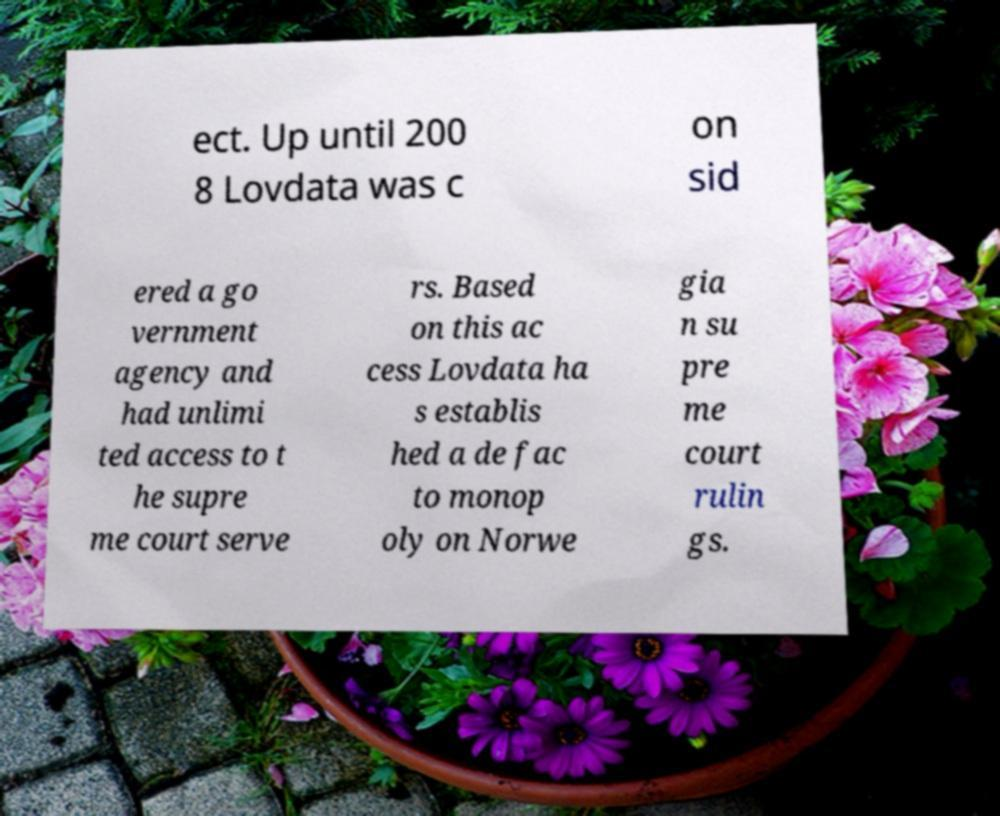I need the written content from this picture converted into text. Can you do that? ect. Up until 200 8 Lovdata was c on sid ered a go vernment agency and had unlimi ted access to t he supre me court serve rs. Based on this ac cess Lovdata ha s establis hed a de fac to monop oly on Norwe gia n su pre me court rulin gs. 